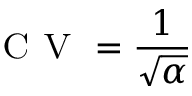<formula> <loc_0><loc_0><loc_500><loc_500>C V = \frac { 1 } { \sqrt { \alpha } }</formula> 